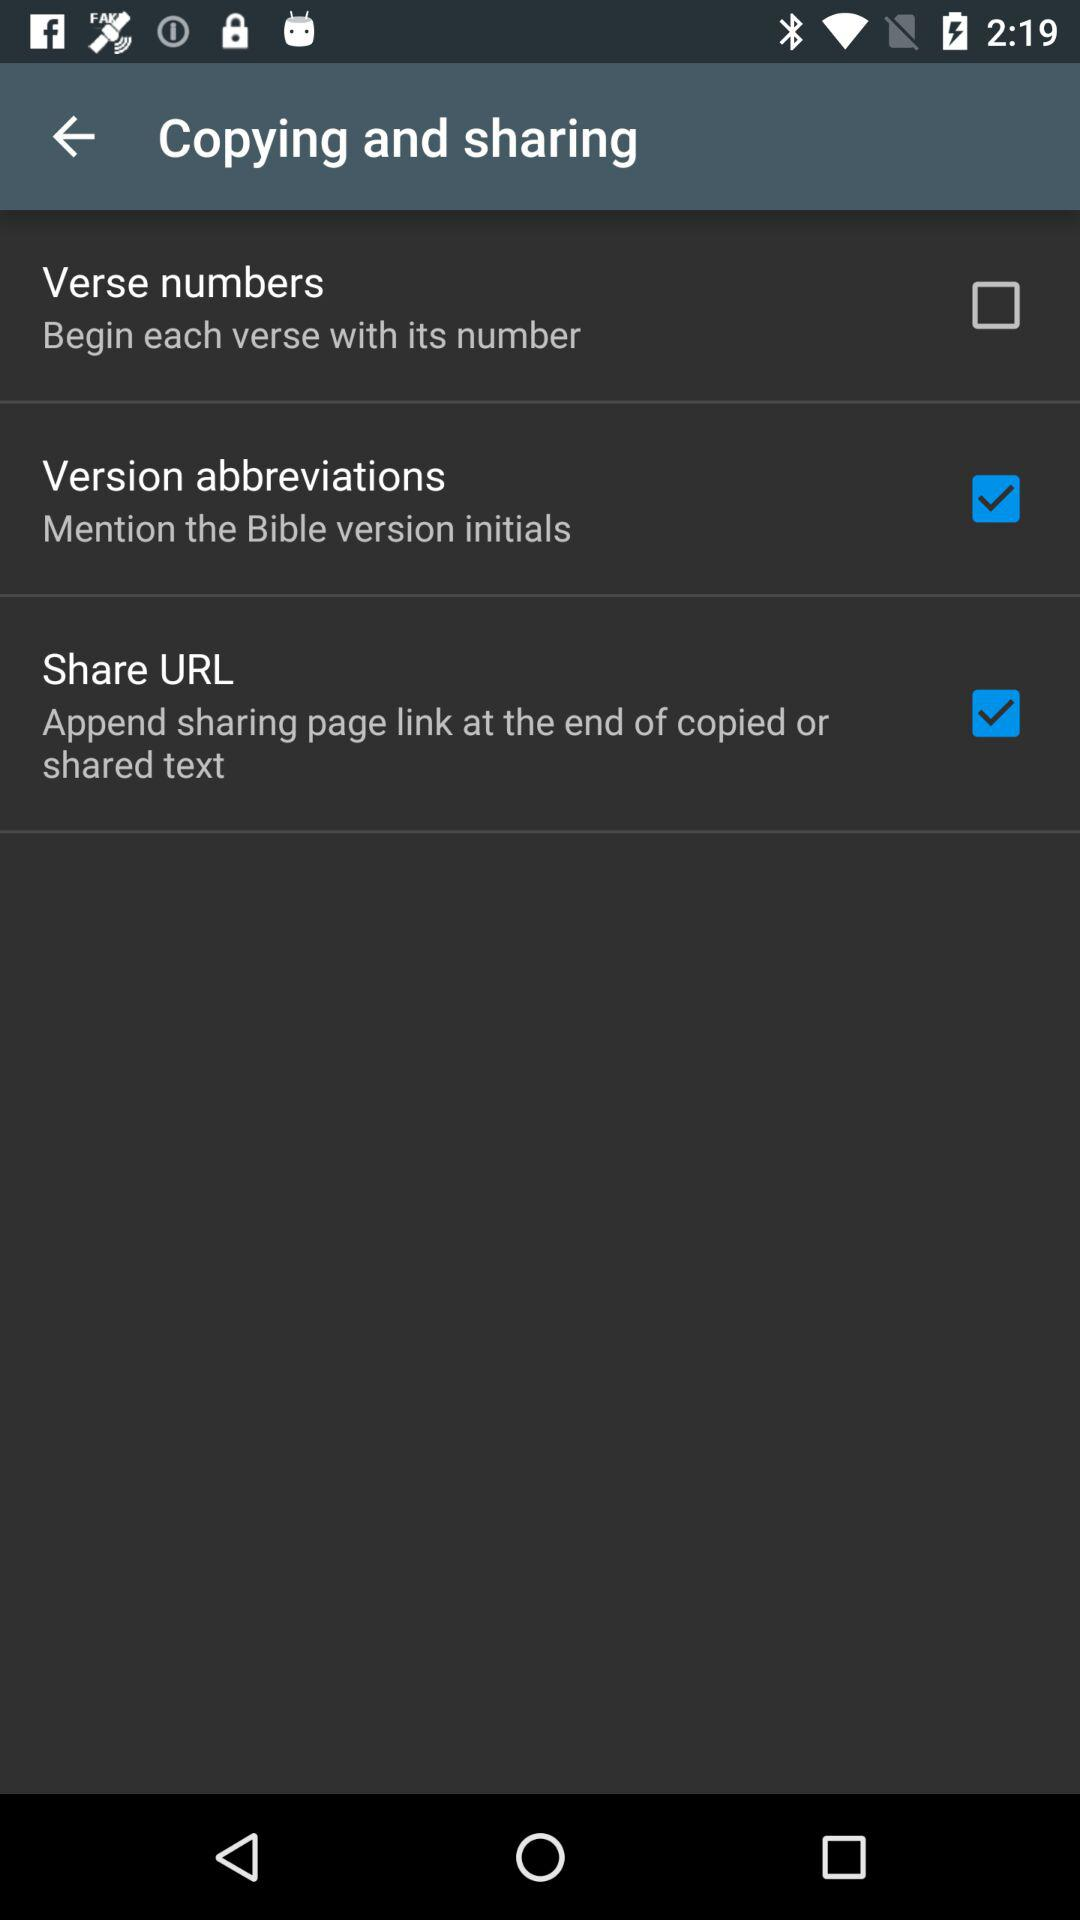What is the current status of "Version abbreviations"? The status is "on". 